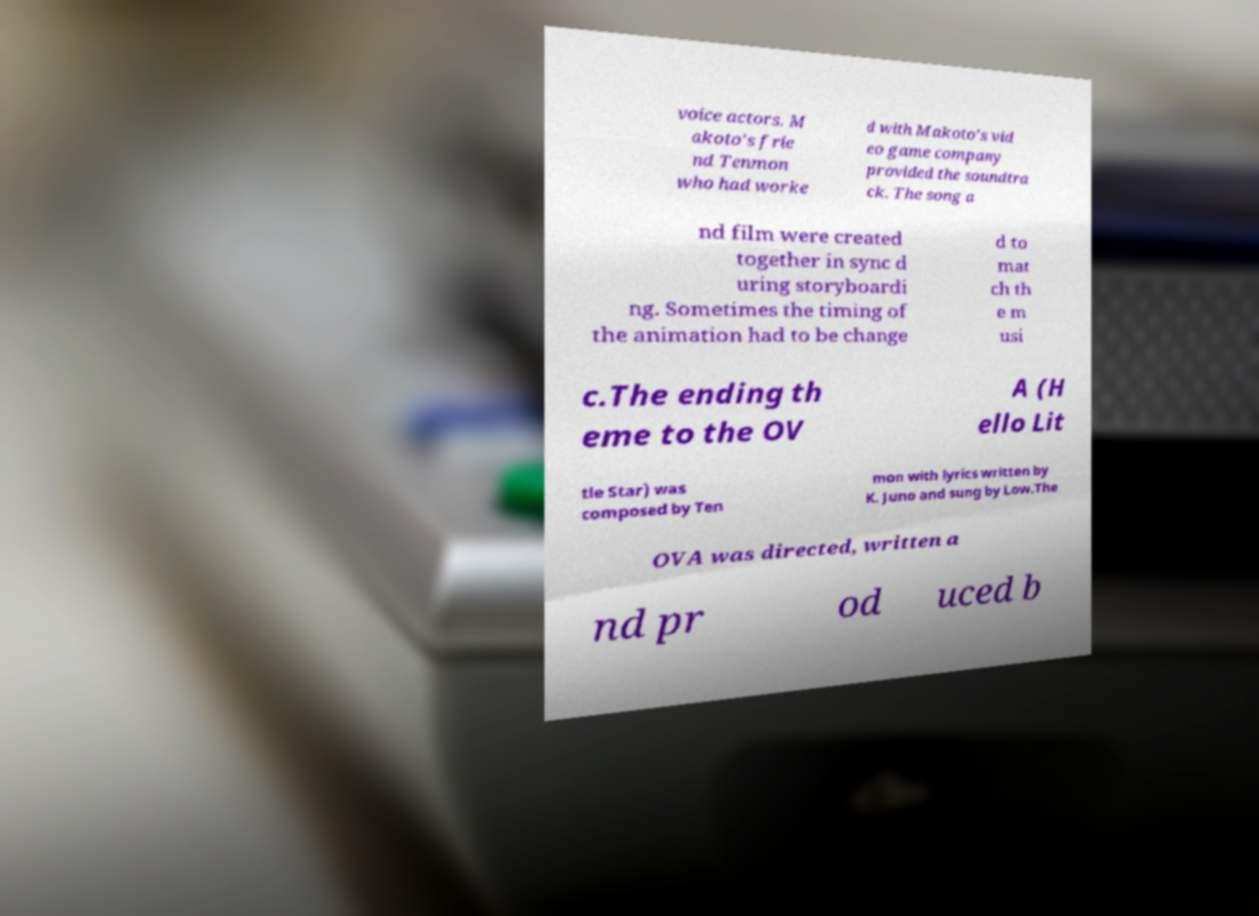Please read and relay the text visible in this image. What does it say? voice actors. M akoto's frie nd Tenmon who had worke d with Makoto's vid eo game company provided the soundtra ck. The song a nd film were created together in sync d uring storyboardi ng. Sometimes the timing of the animation had to be change d to mat ch th e m usi c.The ending th eme to the OV A (H ello Lit tle Star) was composed by Ten mon with lyrics written by K. Juno and sung by Low.The OVA was directed, written a nd pr od uced b 